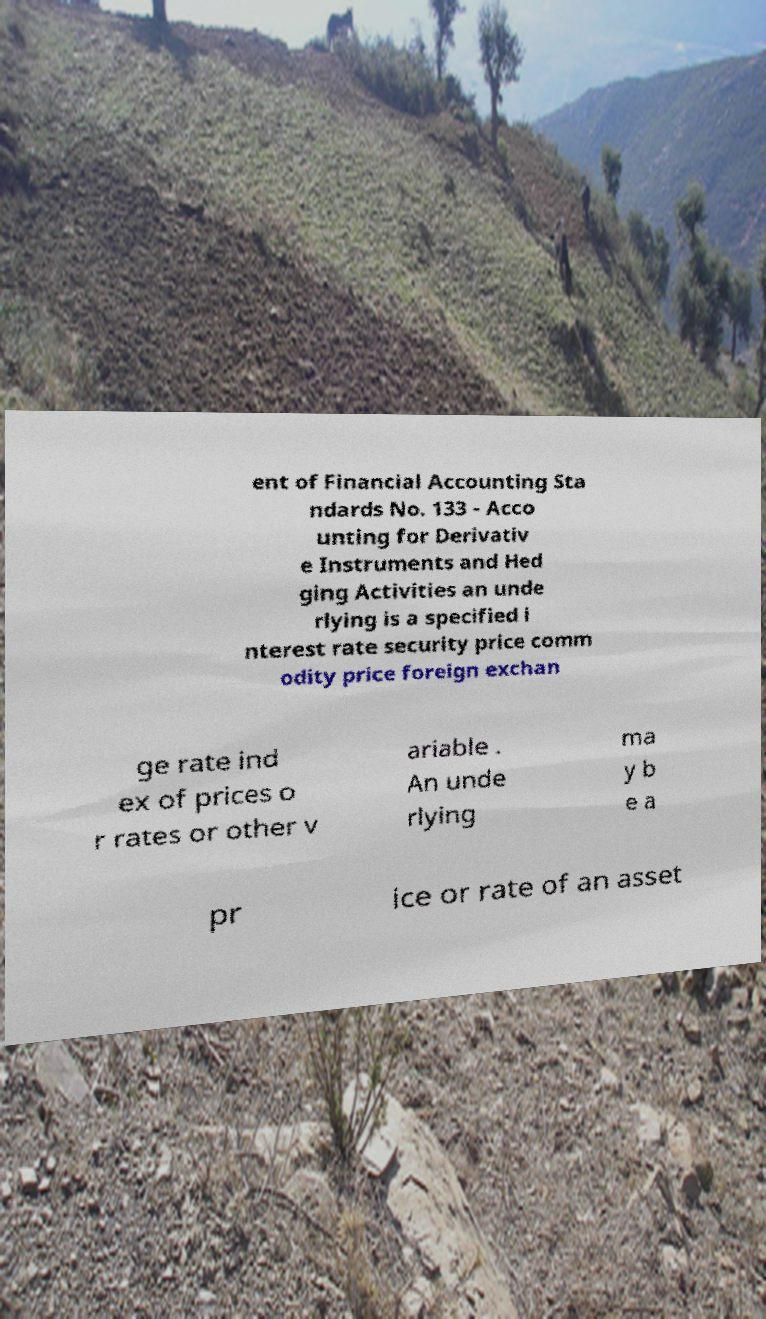Please identify and transcribe the text found in this image. ent of Financial Accounting Sta ndards No. 133 - Acco unting for Derivativ e Instruments and Hed ging Activities an unde rlying is a specified i nterest rate security price comm odity price foreign exchan ge rate ind ex of prices o r rates or other v ariable . An unde rlying ma y b e a pr ice or rate of an asset 